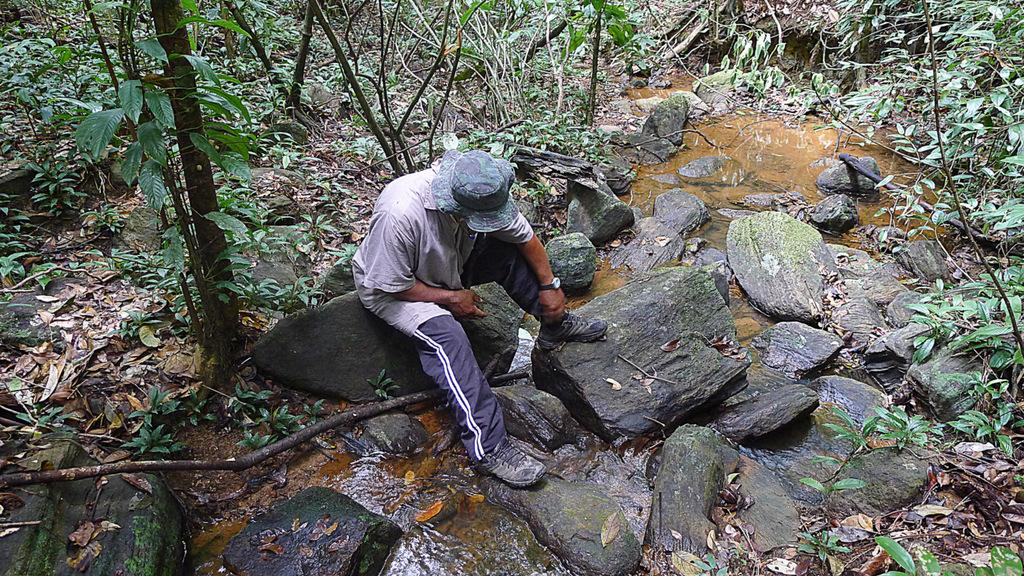What is the main subject of the image? There is a person in the image. What is the person wearing? The person is wearing a dress and a cap. Where is the person sitting in the image? The person is sitting on a rock. What can be seen in the background of the image? There is water and a group of trees visible in the background of the image. What type of fiction is the person reading in the image? There is no book or any form of fiction present in the image. What kind of beast can be seen interacting with the person in the image? There is no beast present in the image; the person is sitting alone on a rock. 